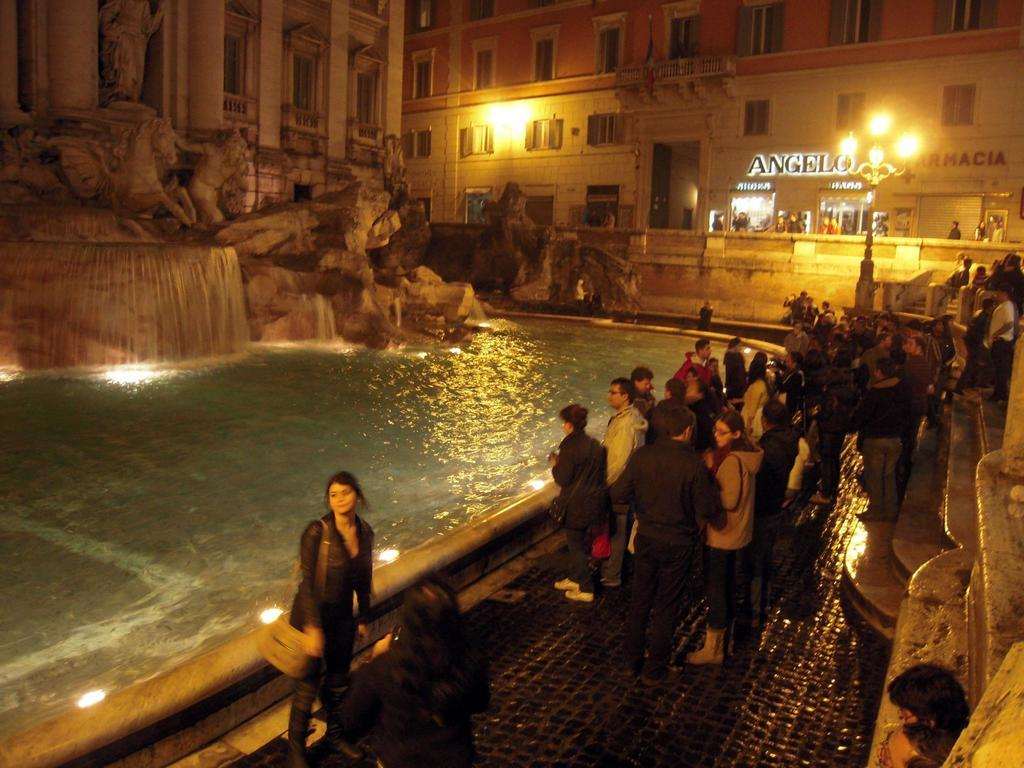What is happening in the image? There are people standing in the image. What is in front of the people? There is water in front of the people. What can be seen in the background of the image? There are buildings in the background of the image. What type of frame is being used to hold the appliance in the image? There is no frame or appliance present in the image; it features people standing near water with buildings in the background. 